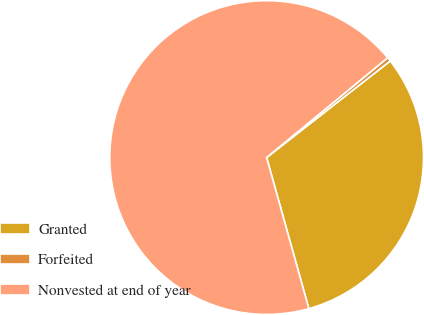Convert chart to OTSL. <chart><loc_0><loc_0><loc_500><loc_500><pie_chart><fcel>Granted<fcel>Forfeited<fcel>Nonvested at end of year<nl><fcel>31.22%<fcel>0.42%<fcel>68.36%<nl></chart> 